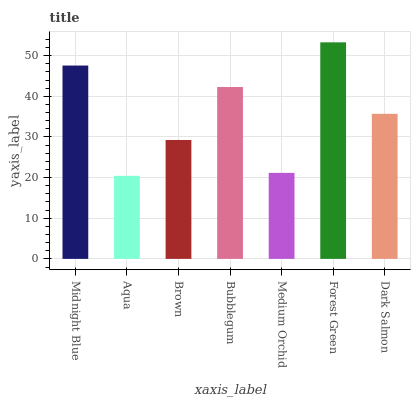Is Aqua the minimum?
Answer yes or no. Yes. Is Forest Green the maximum?
Answer yes or no. Yes. Is Brown the minimum?
Answer yes or no. No. Is Brown the maximum?
Answer yes or no. No. Is Brown greater than Aqua?
Answer yes or no. Yes. Is Aqua less than Brown?
Answer yes or no. Yes. Is Aqua greater than Brown?
Answer yes or no. No. Is Brown less than Aqua?
Answer yes or no. No. Is Dark Salmon the high median?
Answer yes or no. Yes. Is Dark Salmon the low median?
Answer yes or no. Yes. Is Forest Green the high median?
Answer yes or no. No. Is Medium Orchid the low median?
Answer yes or no. No. 